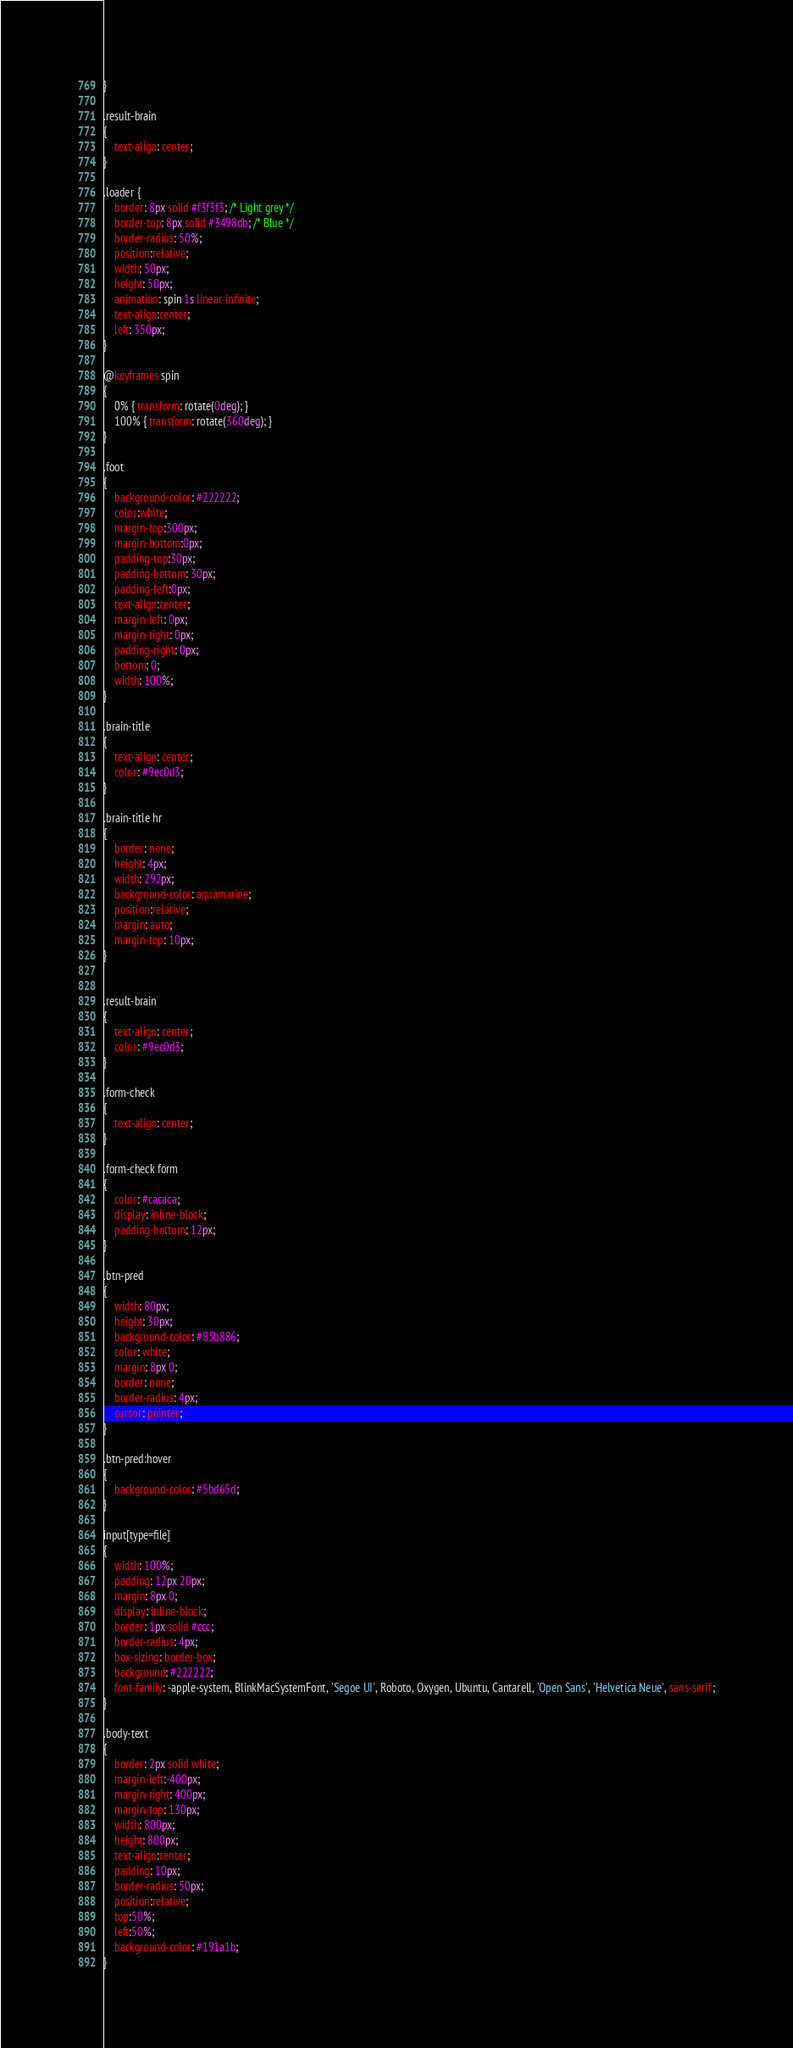Convert code to text. <code><loc_0><loc_0><loc_500><loc_500><_CSS_>}

.result-brain
{
    text-align: center;
}

.loader {
    border: 8px solid #f3f3f3; /* Light grey */
    border-top: 8px solid #3498db; /* Blue */
    border-radius: 50%;
    position:relative;
    width: 50px;
    height: 50px;
    animation: spin 1s linear infinite;
    text-align:center;
    left: 350px;
}

@keyframes spin 
{
    0% { transform: rotate(0deg); }
    100% { transform: rotate(360deg); }
}

.foot
{
    background-color: #222222;
    color:white;
    margin-top:300px;
    margin-bottom:0px;
    padding-top:30px;
    padding-bottom: 30px;
    padding-left:0px;
    text-align:center;
    margin-left: 0px;
    margin-right: 0px;
    padding-right: 0px;
    bottom: 0;
    width: 100%;
}

.brain-title
{
    text-align: center;
    color: #9ec0d3;
}

.brain-title hr
{
    border: none;
    height: 4px;
    width: 292px;
    background-color: aquamarine;
    position:relative;
    margin: auto;
    margin-top: 10px;
}


.result-brain
{
    text-align: center;
    color: #9ec0d3;
}

.form-check
{
    text-align: center;
}

.form-check form
{
    color: #cacaca;
    display: inline-block;
    padding-bottom: 12px;
}

.btn-pred
{
    width: 80px;
    height: 30px;
    background-color: #85b886;
    color: white;
    margin: 8px 0;
    border: none;
    border-radius: 4px;
    cursor: pointer;
}

.btn-pred:hover
{
    background-color: #5bd65d;
}

input[type=file]
{
    width: 100%;
    padding: 12px 20px;
    margin: 8px 0;
    display: inline-block;
    border: 1px solid #ccc;
    border-radius: 4px;
    box-sizing: border-box;
    background: #222222;
    font-family: -apple-system, BlinkMacSystemFont, 'Segoe UI', Roboto, Oxygen, Ubuntu, Cantarell, 'Open Sans', 'Helvetica Neue', sans-serif;
}
  
.body-text
{
    border: 2px solid white;
    margin-left:-400px;
    margin-right: 400px;
    margin-top: 130px;
    width: 800px;
    height: 800px;
    text-align:center;
    padding: 10px;
    border-radius: 50px;
    position:relative;
    top:50%;
    left:50%;
    background-color: #191a1b;
}
</code> 